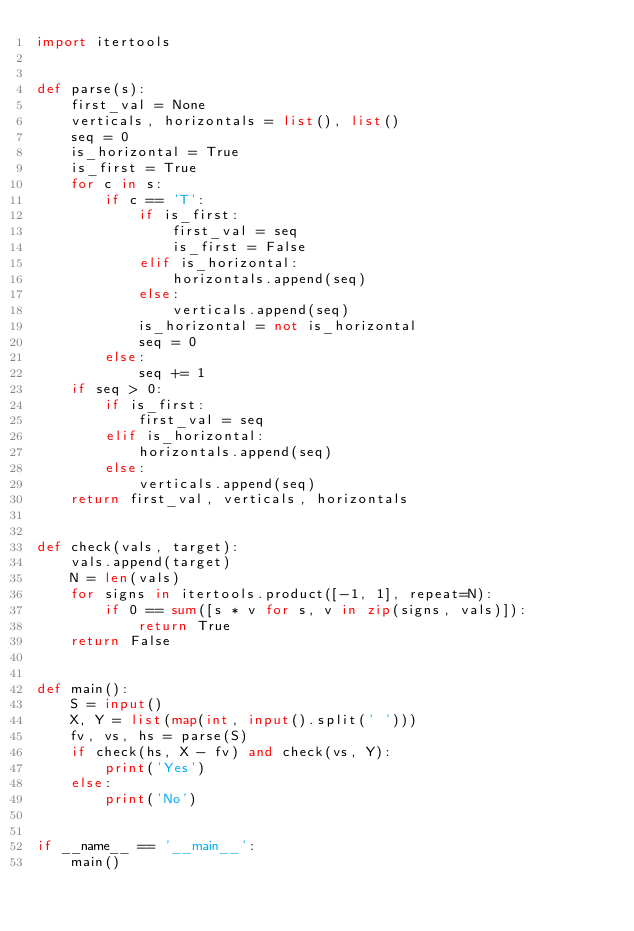<code> <loc_0><loc_0><loc_500><loc_500><_Python_>import itertools


def parse(s):
    first_val = None
    verticals, horizontals = list(), list()
    seq = 0
    is_horizontal = True
    is_first = True
    for c in s:
        if c == 'T':
            if is_first:
                first_val = seq
                is_first = False
            elif is_horizontal:
                horizontals.append(seq)
            else:
                verticals.append(seq)
            is_horizontal = not is_horizontal
            seq = 0
        else:
            seq += 1
    if seq > 0:
        if is_first:
            first_val = seq
        elif is_horizontal:
            horizontals.append(seq)
        else:
            verticals.append(seq)
    return first_val, verticals, horizontals


def check(vals, target):
    vals.append(target)
    N = len(vals)
    for signs in itertools.product([-1, 1], repeat=N):
        if 0 == sum([s * v for s, v in zip(signs, vals)]):
            return True
    return False


def main():
    S = input()
    X, Y = list(map(int, input().split(' ')))
    fv, vs, hs = parse(S)
    if check(hs, X - fv) and check(vs, Y):
        print('Yes')
    else:
        print('No')


if __name__ == '__main__':
    main()</code> 